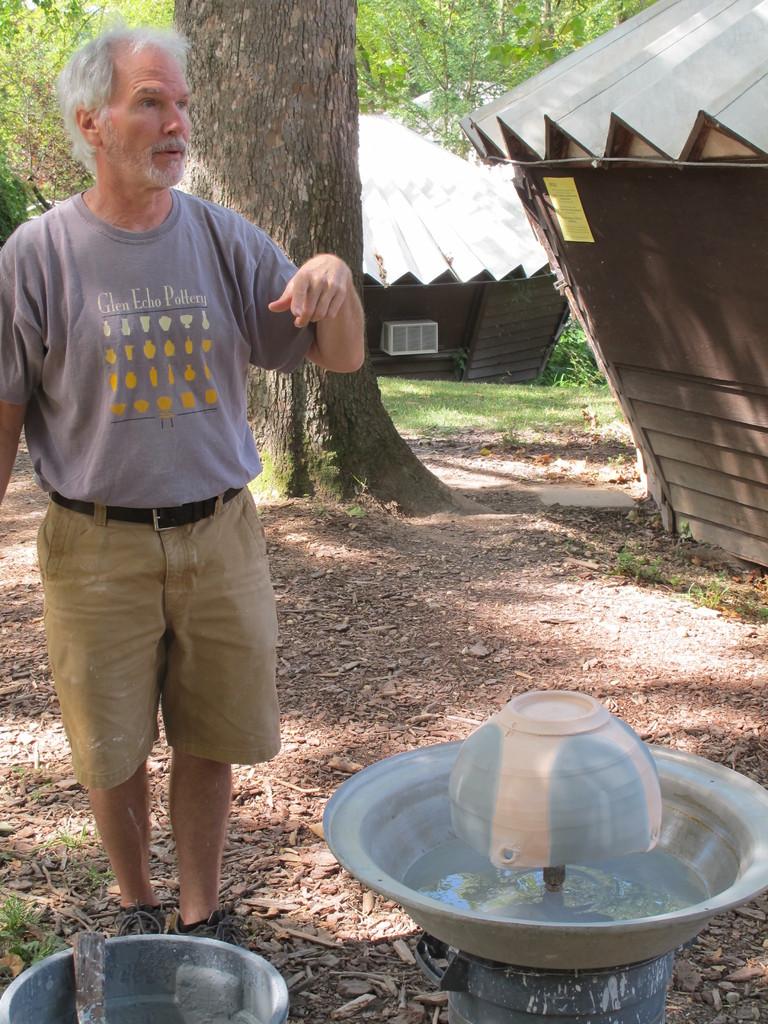What is written on the man's shirt?
Provide a short and direct response. Glen echo pottery. 